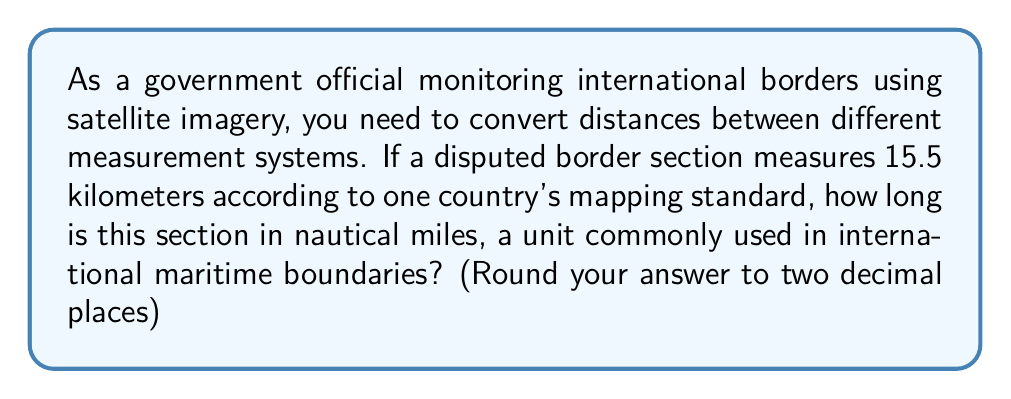What is the answer to this math problem? To solve this problem, we need to convert kilometers to nautical miles. Let's break it down step-by-step:

1. Know the conversion factor:
   1 nautical mile = 1.852 kilometers

2. Set up the conversion equation:
   $$ \frac{15.5 \text{ km}}{x \text{ nautical miles}} = \frac{1.852 \text{ km}}{1 \text{ nautical mile}} $$

3. Cross multiply:
   $$ 15.5 \cdot 1 = 1.852x $$

4. Solve for x:
   $$ x = \frac{15.5}{1.852} $$

5. Calculate:
   $$ x \approx 8.3693 \text{ nautical miles} $$

6. Round to two decimal places:
   $$ x \approx 8.37 \text{ nautical miles} $$

This conversion is crucial for accurately representing border distances in international maritime standards, ensuring consistency in border monitoring and dispute resolution.
Answer: 8.37 nautical miles 